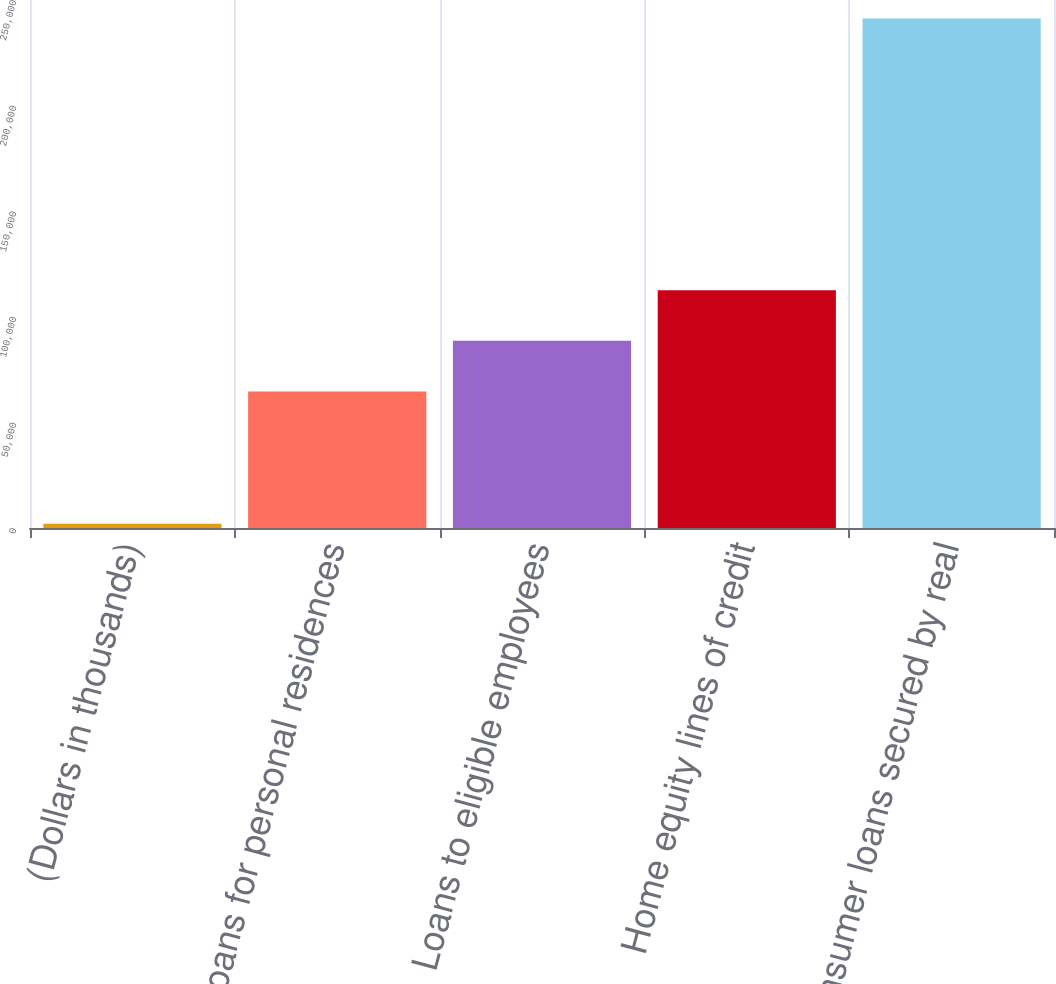Convert chart. <chart><loc_0><loc_0><loc_500><loc_500><bar_chart><fcel>(Dollars in thousands)<fcel>Loans for personal residences<fcel>Loans to eligible employees<fcel>Home equity lines of credit<fcel>Consumer loans secured by real<nl><fcel>2009<fcel>64678<fcel>88605.5<fcel>112533<fcel>241284<nl></chart> 